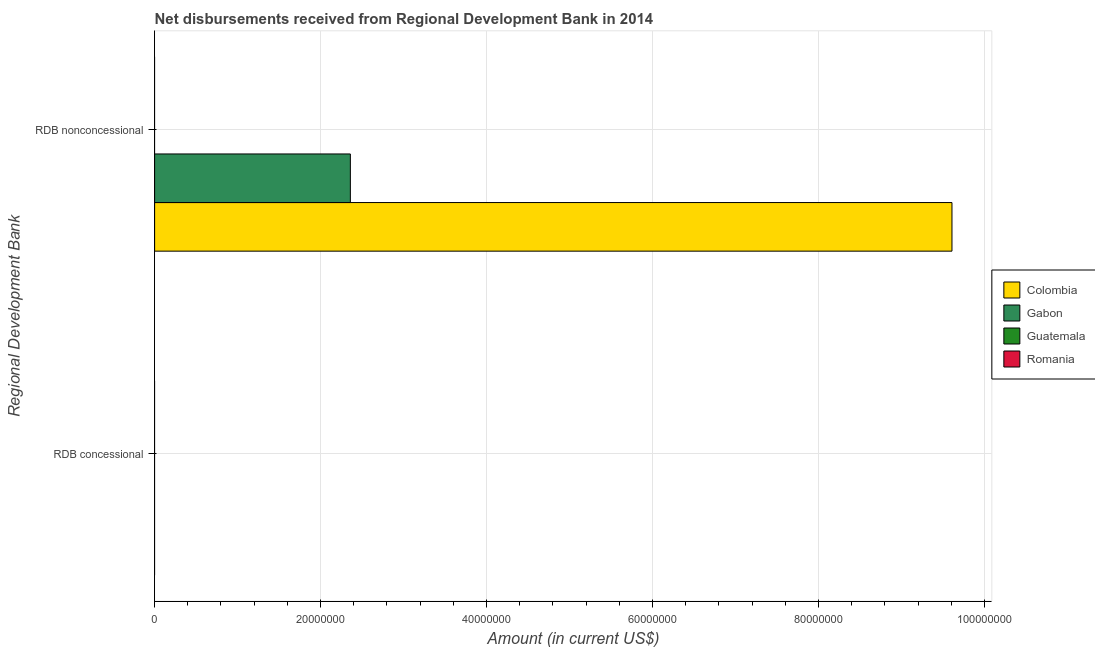How many different coloured bars are there?
Provide a succinct answer. 2. Are the number of bars per tick equal to the number of legend labels?
Ensure brevity in your answer.  No. Are the number of bars on each tick of the Y-axis equal?
Your response must be concise. No. How many bars are there on the 2nd tick from the bottom?
Your response must be concise. 2. What is the label of the 2nd group of bars from the top?
Your answer should be compact. RDB concessional. What is the net non concessional disbursements from rdb in Romania?
Your answer should be compact. 0. Across all countries, what is the maximum net non concessional disbursements from rdb?
Your answer should be very brief. 9.61e+07. Across all countries, what is the minimum net non concessional disbursements from rdb?
Offer a very short reply. 0. What is the total net non concessional disbursements from rdb in the graph?
Keep it short and to the point. 1.20e+08. What is the difference between the net concessional disbursements from rdb in Romania and the net non concessional disbursements from rdb in Gabon?
Keep it short and to the point. -2.36e+07. In how many countries, is the net concessional disbursements from rdb greater than 76000000 US$?
Your answer should be compact. 0. Are all the bars in the graph horizontal?
Your response must be concise. Yes. What is the difference between two consecutive major ticks on the X-axis?
Your response must be concise. 2.00e+07. Does the graph contain any zero values?
Make the answer very short. Yes. Where does the legend appear in the graph?
Keep it short and to the point. Center right. How many legend labels are there?
Provide a succinct answer. 4. How are the legend labels stacked?
Your answer should be very brief. Vertical. What is the title of the graph?
Give a very brief answer. Net disbursements received from Regional Development Bank in 2014. What is the label or title of the Y-axis?
Provide a succinct answer. Regional Development Bank. What is the Amount (in current US$) in Colombia in RDB concessional?
Your answer should be compact. 0. What is the Amount (in current US$) of Gabon in RDB concessional?
Your answer should be compact. 0. What is the Amount (in current US$) of Guatemala in RDB concessional?
Provide a succinct answer. 0. What is the Amount (in current US$) in Romania in RDB concessional?
Provide a succinct answer. 0. What is the Amount (in current US$) of Colombia in RDB nonconcessional?
Ensure brevity in your answer.  9.61e+07. What is the Amount (in current US$) of Gabon in RDB nonconcessional?
Your response must be concise. 2.36e+07. Across all Regional Development Bank, what is the maximum Amount (in current US$) in Colombia?
Your answer should be compact. 9.61e+07. Across all Regional Development Bank, what is the maximum Amount (in current US$) in Gabon?
Ensure brevity in your answer.  2.36e+07. Across all Regional Development Bank, what is the minimum Amount (in current US$) of Gabon?
Ensure brevity in your answer.  0. What is the total Amount (in current US$) in Colombia in the graph?
Your answer should be compact. 9.61e+07. What is the total Amount (in current US$) of Gabon in the graph?
Offer a terse response. 2.36e+07. What is the total Amount (in current US$) in Romania in the graph?
Provide a succinct answer. 0. What is the average Amount (in current US$) of Colombia per Regional Development Bank?
Your answer should be very brief. 4.80e+07. What is the average Amount (in current US$) of Gabon per Regional Development Bank?
Offer a very short reply. 1.18e+07. What is the average Amount (in current US$) in Guatemala per Regional Development Bank?
Give a very brief answer. 0. What is the difference between the Amount (in current US$) of Colombia and Amount (in current US$) of Gabon in RDB nonconcessional?
Offer a terse response. 7.25e+07. What is the difference between the highest and the lowest Amount (in current US$) of Colombia?
Make the answer very short. 9.61e+07. What is the difference between the highest and the lowest Amount (in current US$) of Gabon?
Your response must be concise. 2.36e+07. 